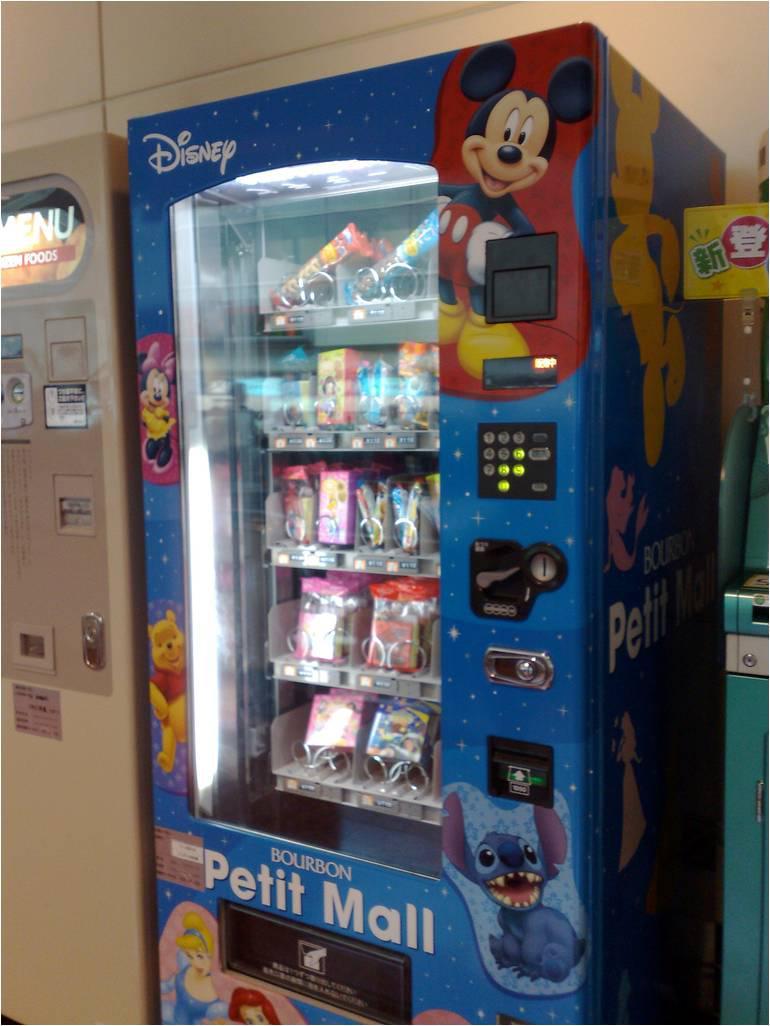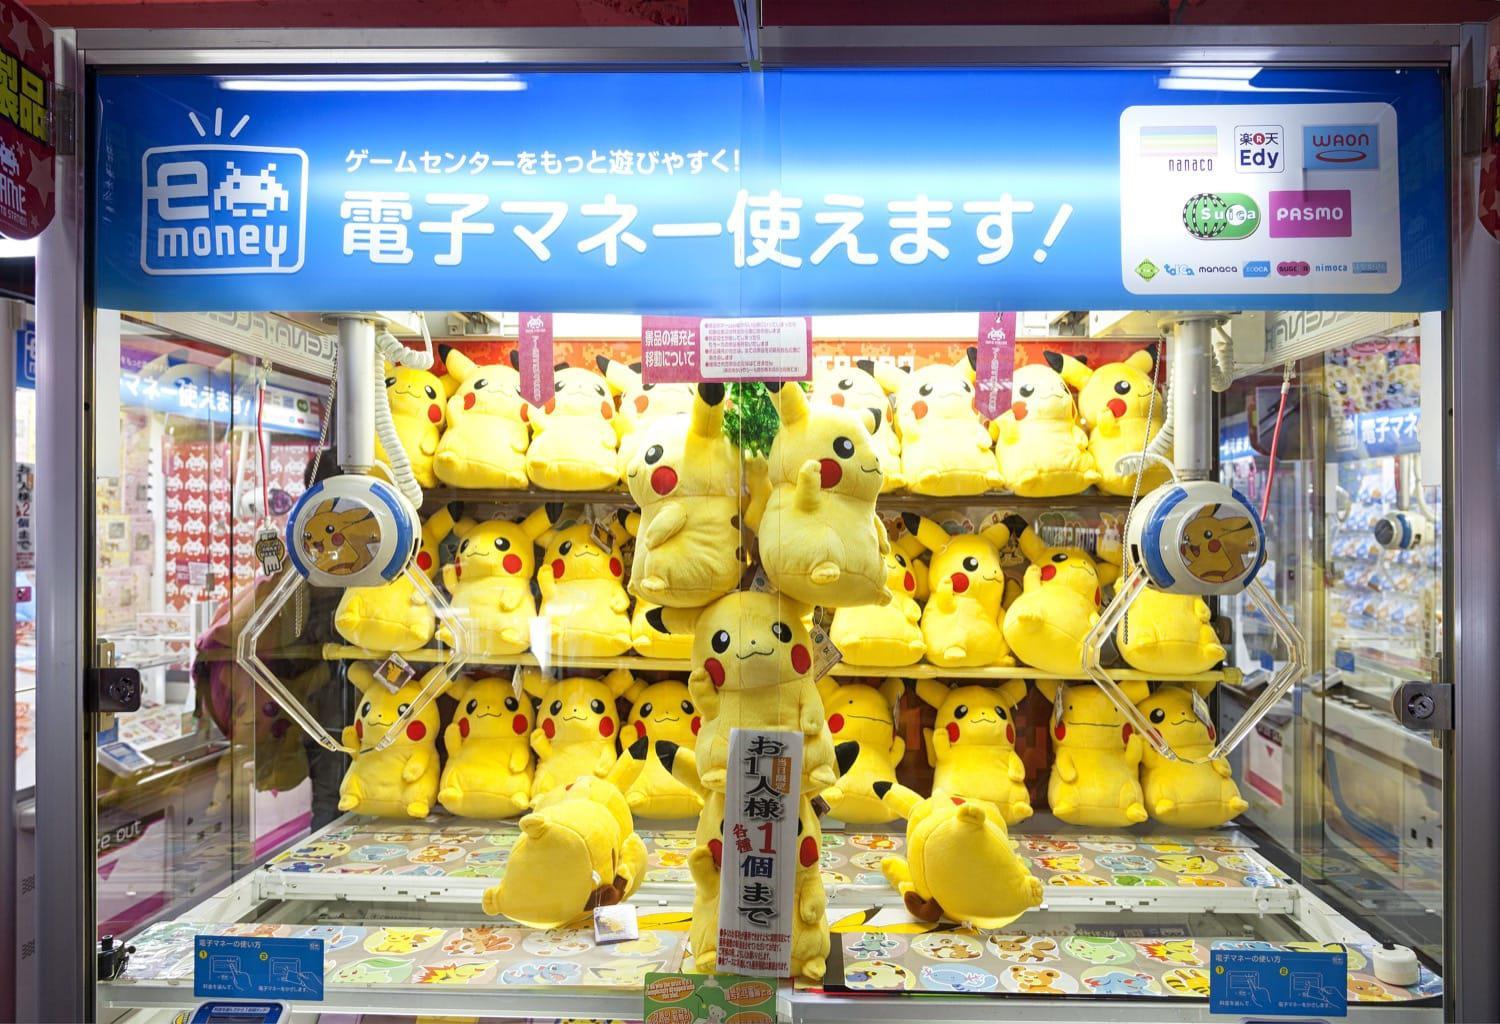The first image is the image on the left, the second image is the image on the right. Given the left and right images, does the statement "An image shows two straight stacked rows of vending machines, at least 8 across." hold true? Answer yes or no. No. 